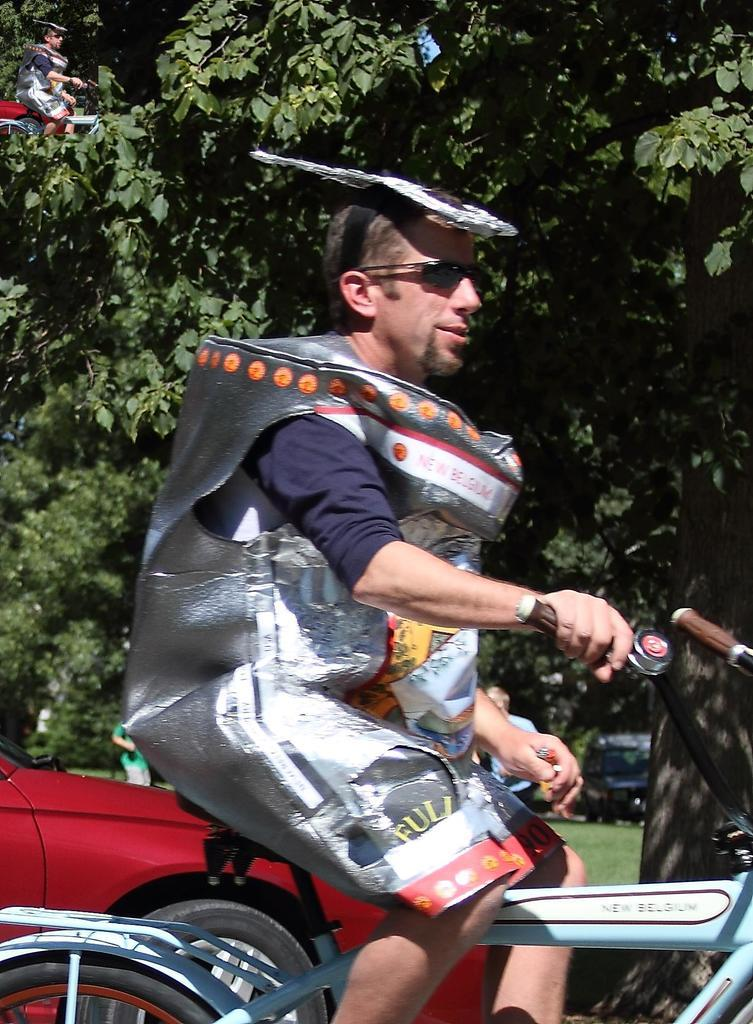What is the man in the image doing? The man is riding a bicycle in the image. What can be seen in the background of the image? There is a car and a tree in the background of the image. Can you tell me how many pigs are running alongside the man in the image? There are no pigs present in the image; it only features a man riding a bicycle and a car and a tree in the background. What type of prose is the man reciting while riding the bicycle in the image? There is no indication in the image that the man is reciting any prose while riding the bicycle. 